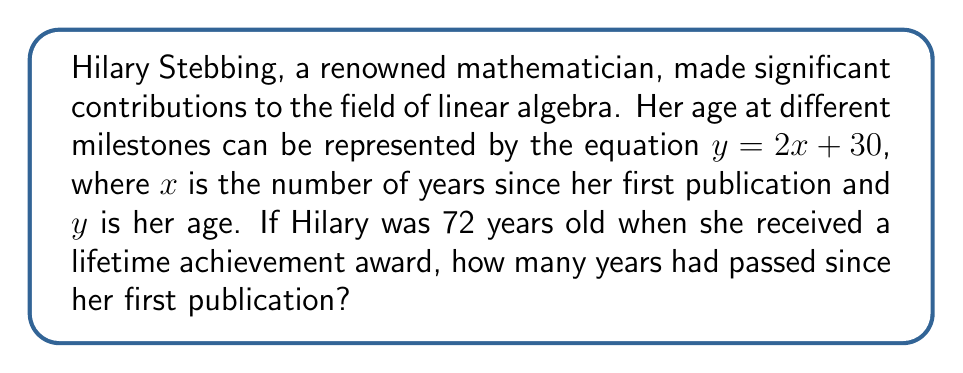What is the answer to this math problem? Let's solve this step-by-step:

1) We are given the linear equation: $y = 2x + 30$

2) We know that when Hilary received the award, her age ($y$) was 72.

3) Let's substitute this information into the equation:
   $72 = 2x + 30$

4) To solve for $x$, we first subtract 30 from both sides:
   $72 - 30 = 2x + 30 - 30$
   $42 = 2x$

5) Now, we divide both sides by 2:
   $\frac{42}{2} = \frac{2x}{2}$
   $21 = x$

6) Therefore, 21 years had passed since Hilary's first publication when she received the lifetime achievement award.
Answer: 21 years 